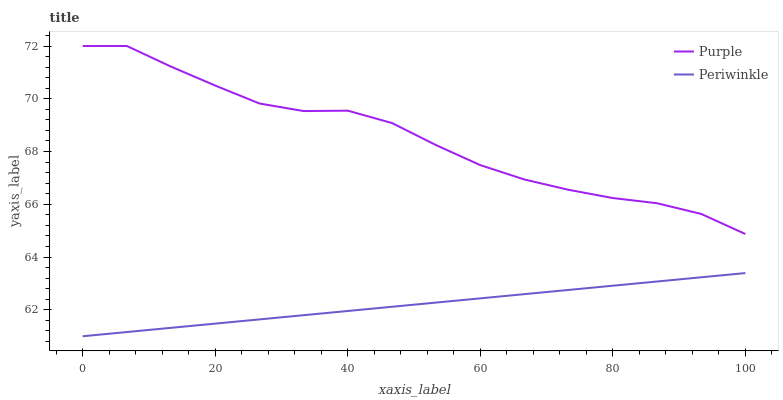Does Periwinkle have the minimum area under the curve?
Answer yes or no. Yes. Does Purple have the maximum area under the curve?
Answer yes or no. Yes. Does Periwinkle have the maximum area under the curve?
Answer yes or no. No. Is Periwinkle the smoothest?
Answer yes or no. Yes. Is Purple the roughest?
Answer yes or no. Yes. Is Periwinkle the roughest?
Answer yes or no. No. Does Periwinkle have the lowest value?
Answer yes or no. Yes. Does Purple have the highest value?
Answer yes or no. Yes. Does Periwinkle have the highest value?
Answer yes or no. No. Is Periwinkle less than Purple?
Answer yes or no. Yes. Is Purple greater than Periwinkle?
Answer yes or no. Yes. Does Periwinkle intersect Purple?
Answer yes or no. No. 